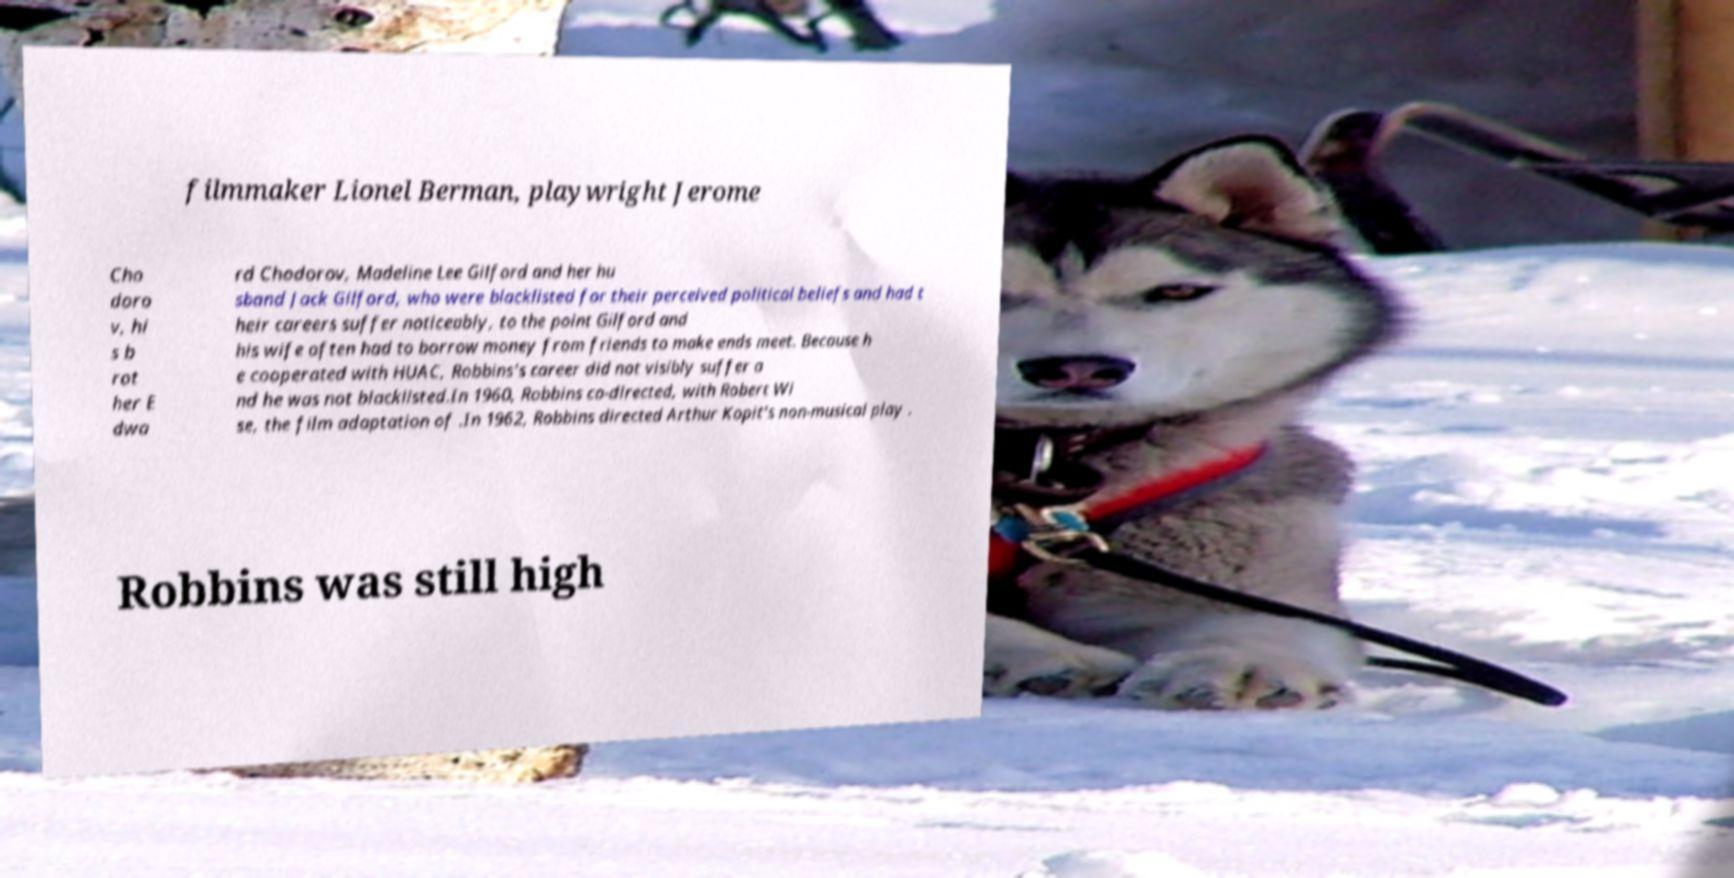Please read and relay the text visible in this image. What does it say? filmmaker Lionel Berman, playwright Jerome Cho doro v, hi s b rot her E dwa rd Chodorov, Madeline Lee Gilford and her hu sband Jack Gilford, who were blacklisted for their perceived political beliefs and had t heir careers suffer noticeably, to the point Gilford and his wife often had to borrow money from friends to make ends meet. Because h e cooperated with HUAC, Robbins's career did not visibly suffer a nd he was not blacklisted.In 1960, Robbins co-directed, with Robert Wi se, the film adaptation of .In 1962, Robbins directed Arthur Kopit's non-musical play . Robbins was still high 